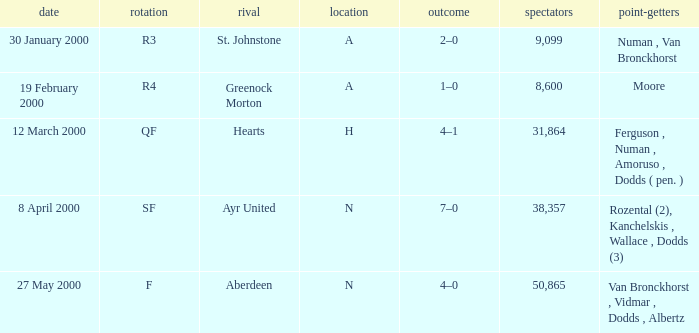Who was on 12 March 2000? Ferguson , Numan , Amoruso , Dodds ( pen. ). 